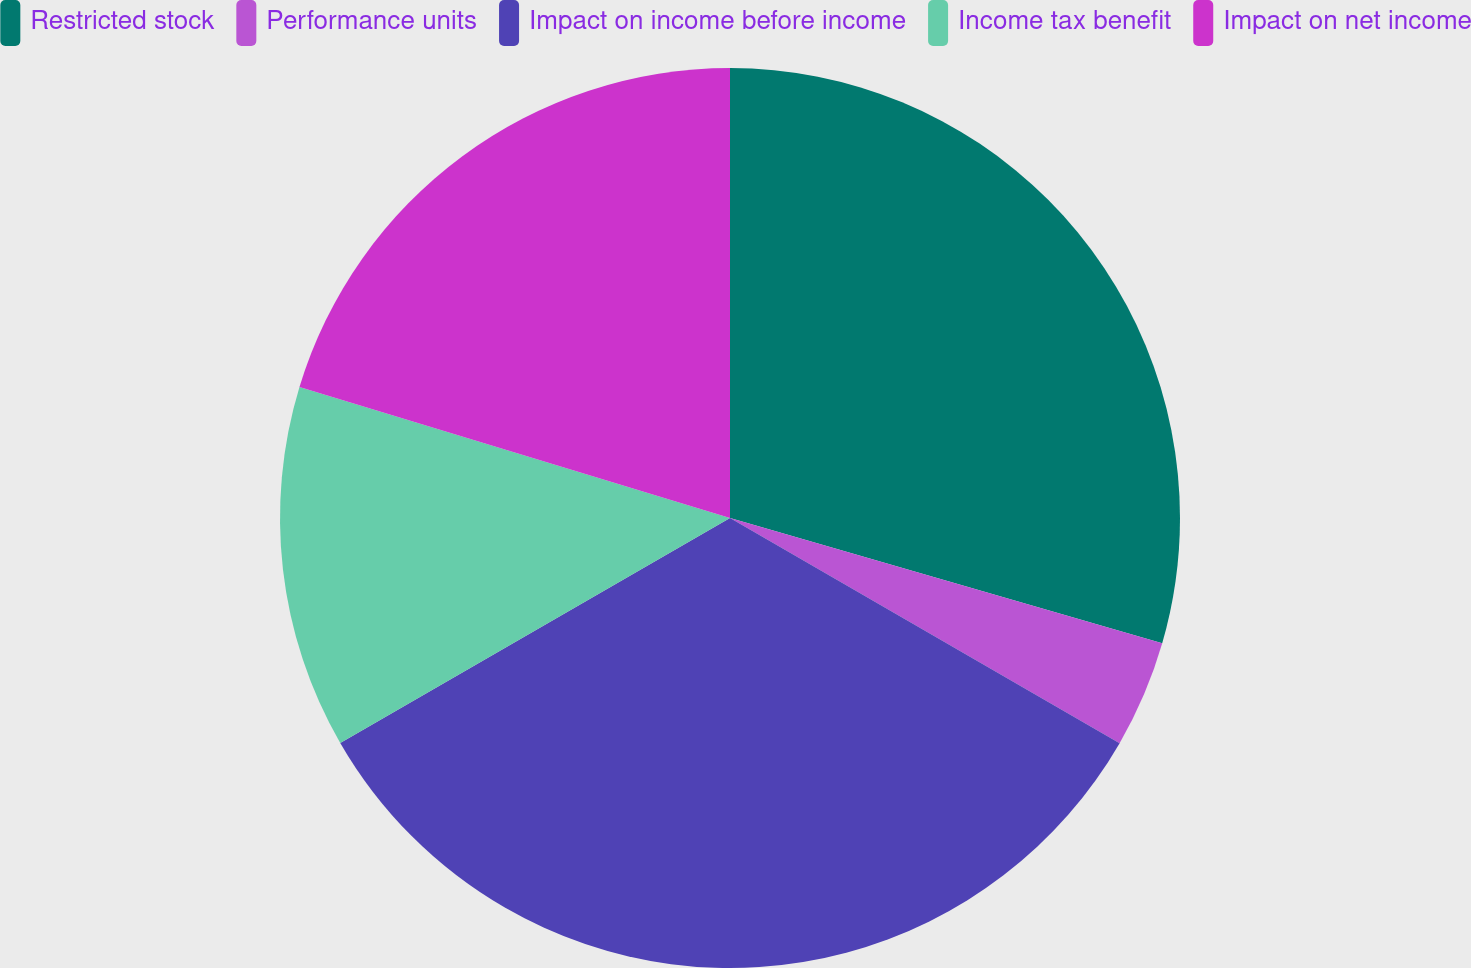<chart> <loc_0><loc_0><loc_500><loc_500><pie_chart><fcel>Restricted stock<fcel>Performance units<fcel>Impact on income before income<fcel>Income tax benefit<fcel>Impact on net income<nl><fcel>29.49%<fcel>3.85%<fcel>33.33%<fcel>13.03%<fcel>20.3%<nl></chart> 